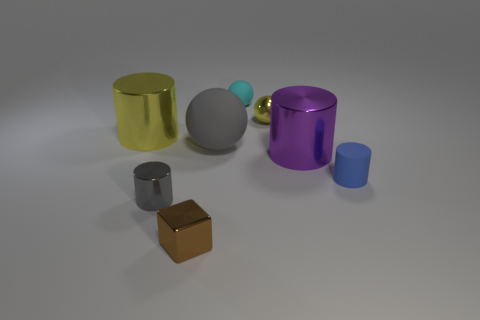Is the number of gray metal things on the right side of the small brown cube less than the number of purple cylinders that are right of the tiny matte cylinder?
Keep it short and to the point. No. What color is the tiny metal block?
Keep it short and to the point. Brown. What number of tiny metal cylinders are the same color as the large sphere?
Offer a very short reply. 1. Are there any small metallic spheres behind the shiny sphere?
Your response must be concise. No. Is the number of tiny rubber objects that are in front of the tiny blue matte object the same as the number of large yellow cylinders that are in front of the big yellow metallic thing?
Offer a terse response. Yes. Does the yellow object to the left of the small yellow thing have the same size as the blue matte thing behind the gray metal cylinder?
Your answer should be very brief. No. What shape is the rubber object that is behind the yellow object that is in front of the small sphere that is right of the small cyan matte ball?
Ensure brevity in your answer.  Sphere. Is there any other thing that is made of the same material as the tiny blue cylinder?
Your answer should be very brief. Yes. What size is the other metallic object that is the same shape as the big gray object?
Your answer should be compact. Small. What is the color of the tiny metal thing that is both in front of the large purple metal cylinder and behind the tiny brown metal cube?
Provide a succinct answer. Gray. 